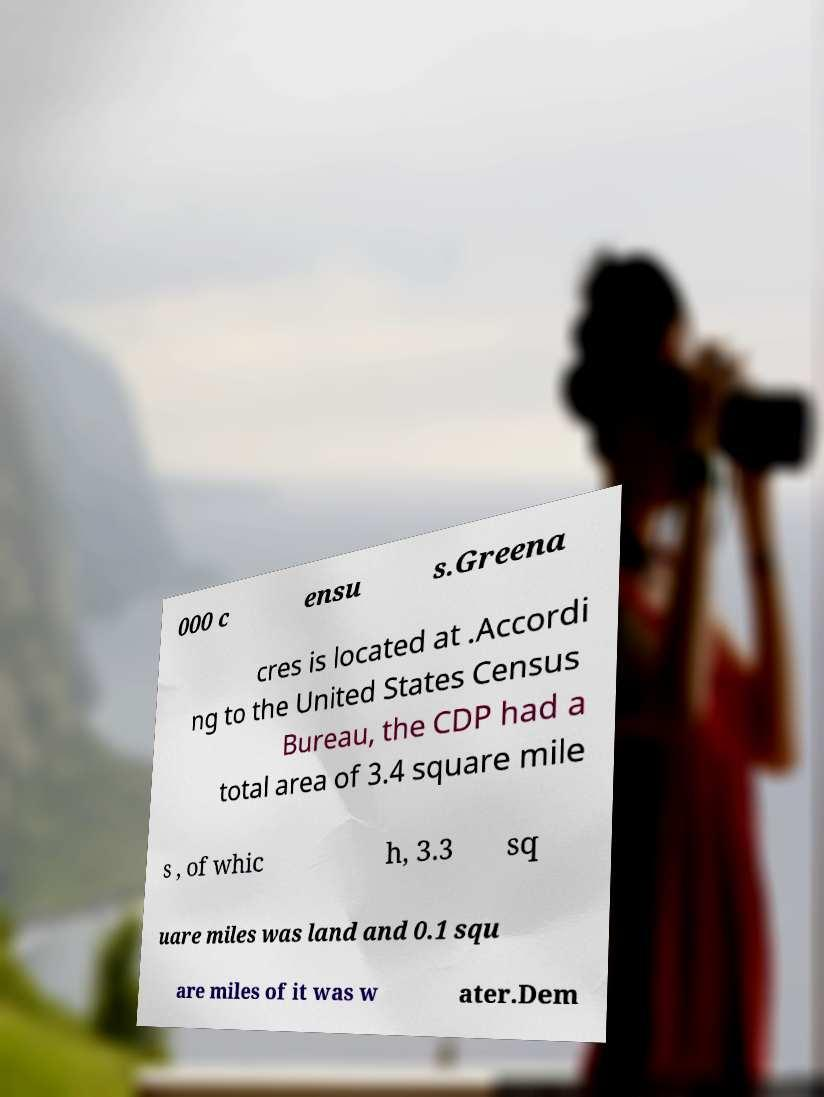Please identify and transcribe the text found in this image. 000 c ensu s.Greena cres is located at .Accordi ng to the United States Census Bureau, the CDP had a total area of 3.4 square mile s , of whic h, 3.3 sq uare miles was land and 0.1 squ are miles of it was w ater.Dem 